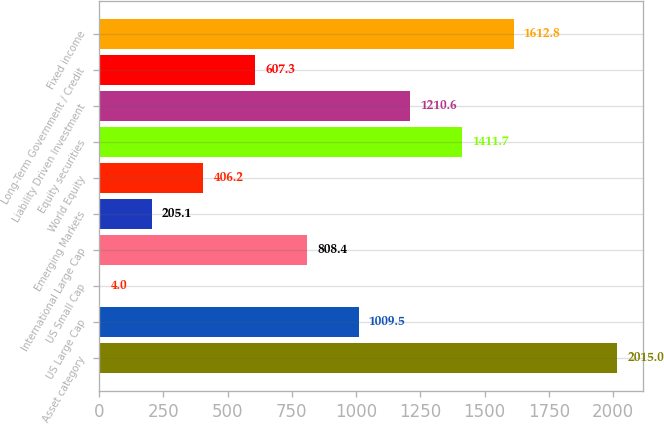Convert chart. <chart><loc_0><loc_0><loc_500><loc_500><bar_chart><fcel>Asset category<fcel>US Large Cap<fcel>US Small Cap<fcel>International Large Cap<fcel>Emerging Markets<fcel>World Equity<fcel>Equity securities<fcel>Liability Driven Investment<fcel>Long-Term Government / Credit<fcel>Fixed income<nl><fcel>2015<fcel>1009.5<fcel>4<fcel>808.4<fcel>205.1<fcel>406.2<fcel>1411.7<fcel>1210.6<fcel>607.3<fcel>1612.8<nl></chart> 